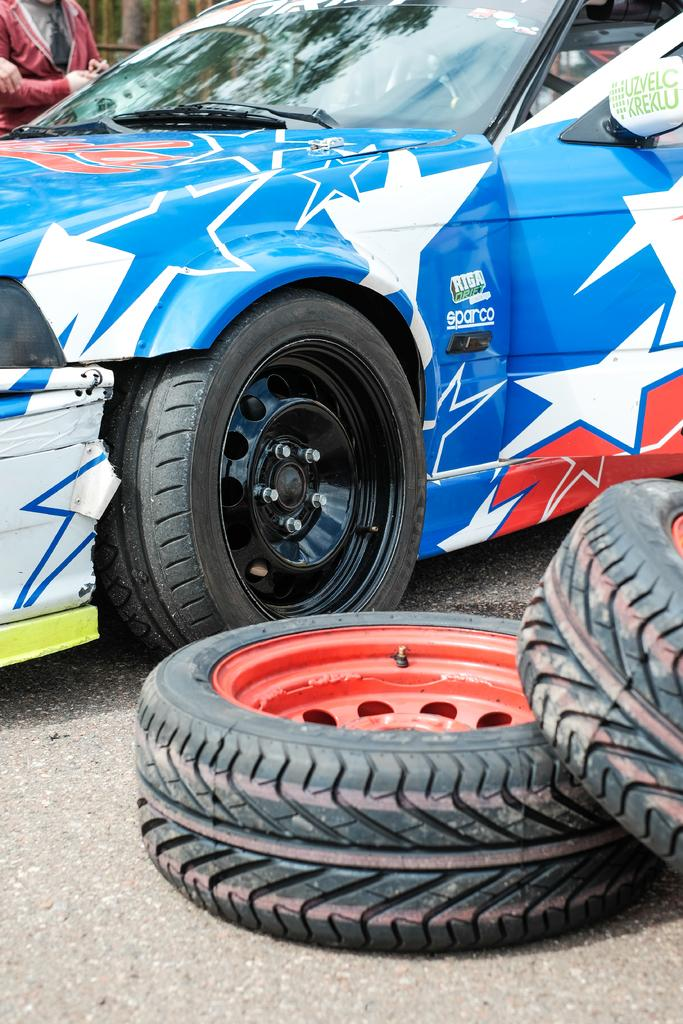What type of motor vehicle is in the image? The image contains a motor vehicle, but the specific type is not mentioned. What part of the motor vehicle can be seen in the image? Tyres are visible in the image. What is the person on the ground doing in the image? The person's actions are not described in the provided facts. What type of plantation is visible in the image? There is no plantation present in the image. What is the person's interest in the motor vehicle, and how does it relate to the alarm? The provided facts do not mention any interest or alarm related to the person or the motor vehicle. 